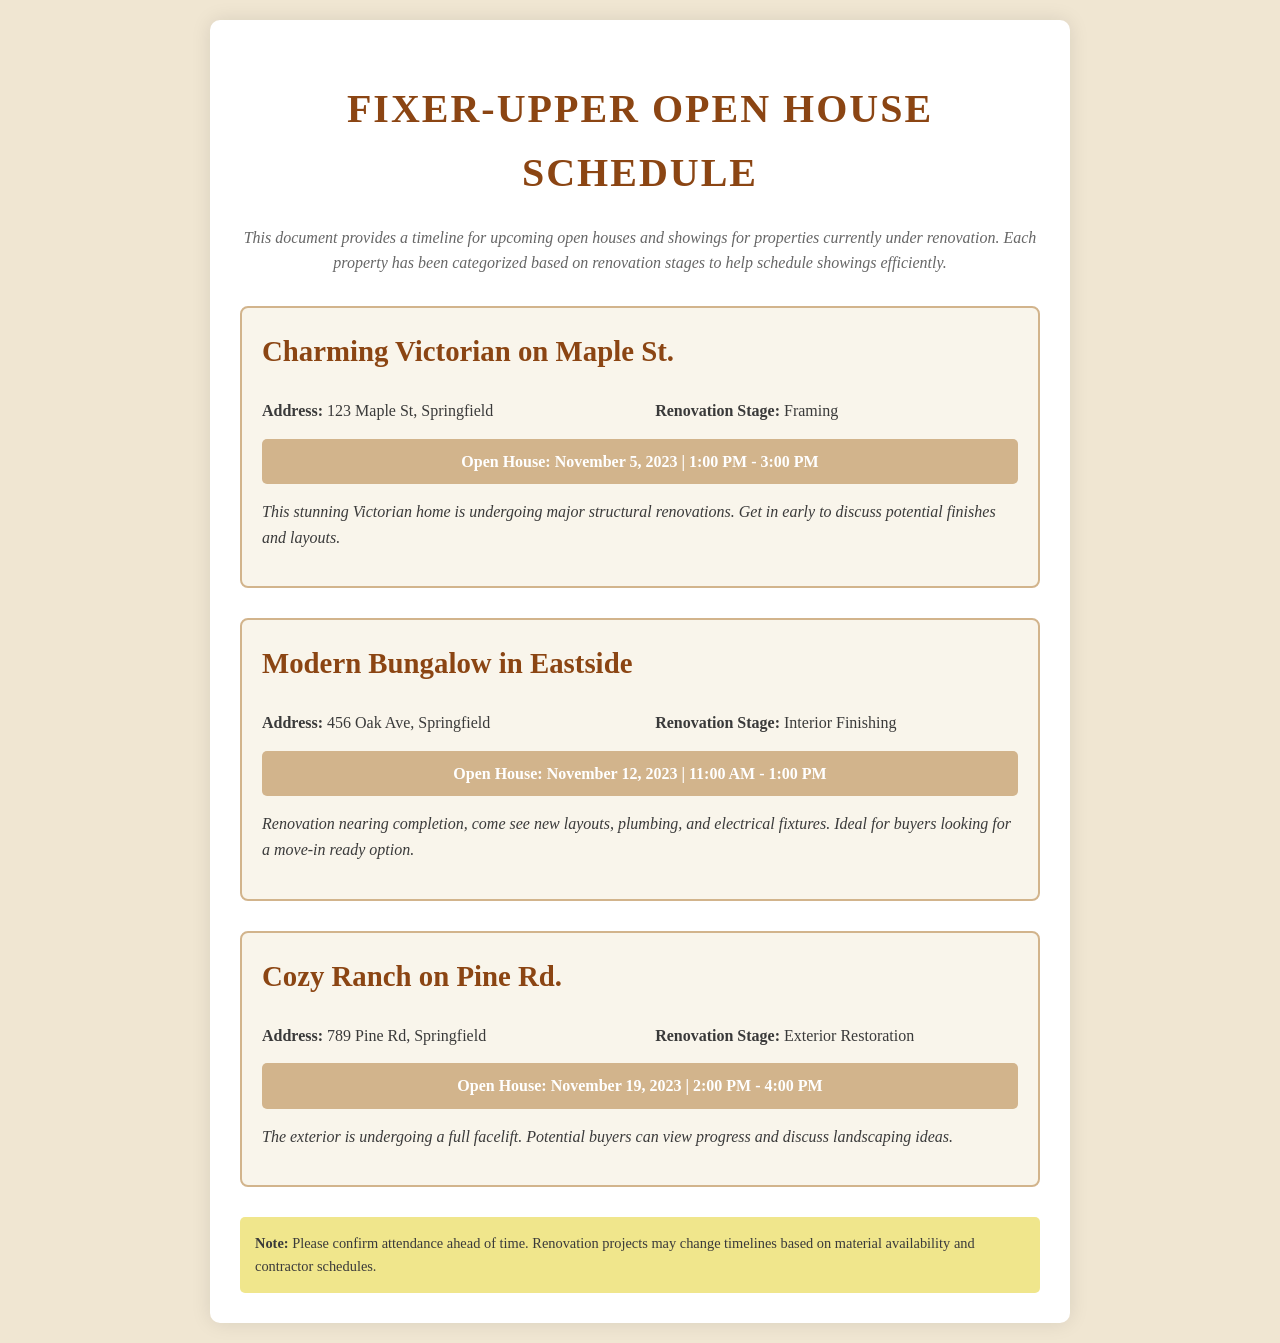What is the address of the Charming Victorian? The address of the Charming Victorian is provided in the property details section.
Answer: 123 Maple St, Springfield What is the renovation stage of the Modern Bungalow? The renovation stage is mentioned alongside the property details.
Answer: Interior Finishing What renovations are being done at the Charming Victorian? The renovation stage provides insight into the types of renovations occurring at the property.
Answer: Major structural renovations How many properties have open houses scheduled in November? The document lists all properties with their open house dates in November.
Answer: Three properties Which property is scheduled for an open house first? The open house dates allow for chronological comparison to determine which property is first.
Answer: Charming Victorian on Maple St What should attendees do ahead of time? The note at the end of the document provides recommendations for attendees.
Answer: Confirm attendance What type of renovation is ongoing at the Cozy Ranch? The renovation stage indicates the specific type of renovation happening at that property.
Answer: Exterior Restoration 